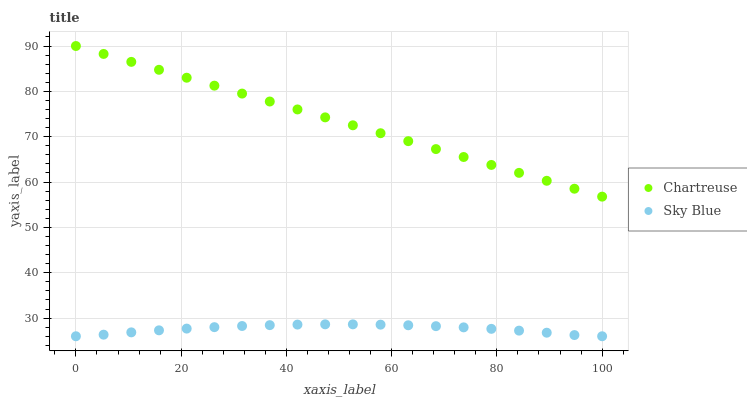Does Sky Blue have the minimum area under the curve?
Answer yes or no. Yes. Does Chartreuse have the maximum area under the curve?
Answer yes or no. Yes. Does Chartreuse have the minimum area under the curve?
Answer yes or no. No. Is Chartreuse the smoothest?
Answer yes or no. Yes. Is Sky Blue the roughest?
Answer yes or no. Yes. Is Chartreuse the roughest?
Answer yes or no. No. Does Sky Blue have the lowest value?
Answer yes or no. Yes. Does Chartreuse have the lowest value?
Answer yes or no. No. Does Chartreuse have the highest value?
Answer yes or no. Yes. Is Sky Blue less than Chartreuse?
Answer yes or no. Yes. Is Chartreuse greater than Sky Blue?
Answer yes or no. Yes. Does Sky Blue intersect Chartreuse?
Answer yes or no. No. 